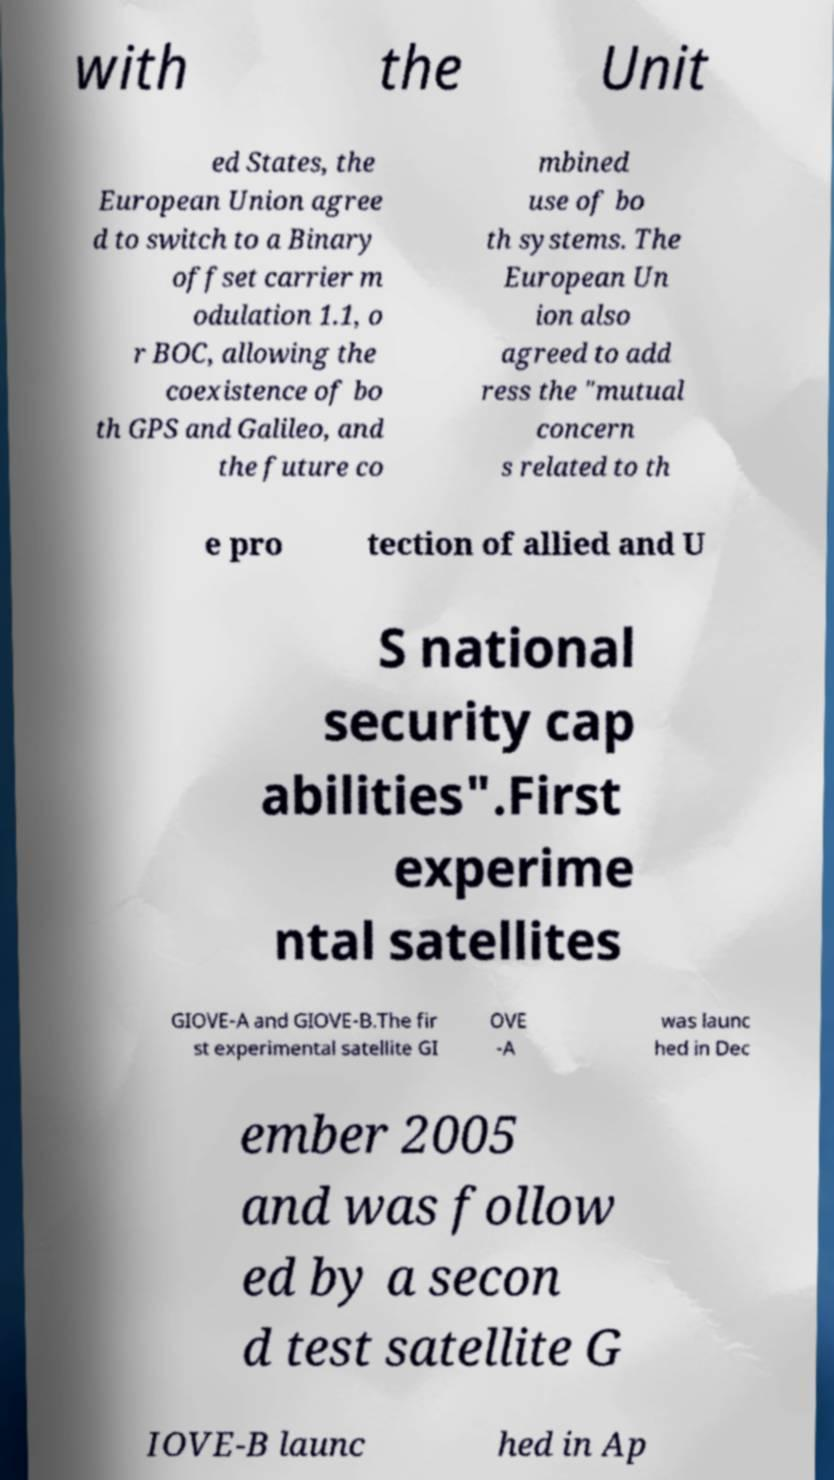Could you assist in decoding the text presented in this image and type it out clearly? with the Unit ed States, the European Union agree d to switch to a Binary offset carrier m odulation 1.1, o r BOC, allowing the coexistence of bo th GPS and Galileo, and the future co mbined use of bo th systems. The European Un ion also agreed to add ress the "mutual concern s related to th e pro tection of allied and U S national security cap abilities".First experime ntal satellites GIOVE-A and GIOVE-B.The fir st experimental satellite GI OVE -A was launc hed in Dec ember 2005 and was follow ed by a secon d test satellite G IOVE-B launc hed in Ap 